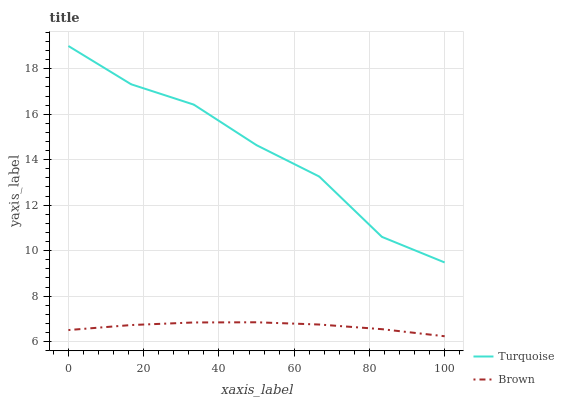Does Brown have the minimum area under the curve?
Answer yes or no. Yes. Does Turquoise have the maximum area under the curve?
Answer yes or no. Yes. Does Turquoise have the minimum area under the curve?
Answer yes or no. No. Is Brown the smoothest?
Answer yes or no. Yes. Is Turquoise the roughest?
Answer yes or no. Yes. Is Turquoise the smoothest?
Answer yes or no. No. Does Brown have the lowest value?
Answer yes or no. Yes. Does Turquoise have the lowest value?
Answer yes or no. No. Does Turquoise have the highest value?
Answer yes or no. Yes. Is Brown less than Turquoise?
Answer yes or no. Yes. Is Turquoise greater than Brown?
Answer yes or no. Yes. Does Brown intersect Turquoise?
Answer yes or no. No. 